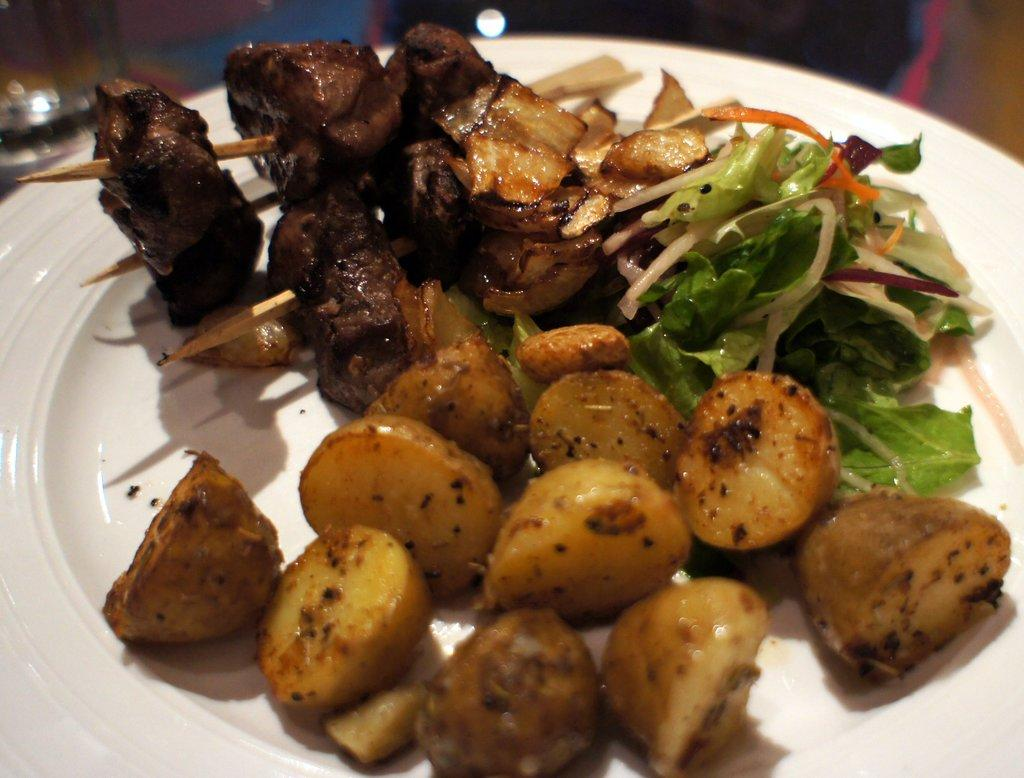What is present on the plate in the image? There is food in a plate in the image. What type of bird can be seen regretting its decision to fly near the plate in the image? There is no bird present in the image, let alone one regretting its decision to fly near the plate. 